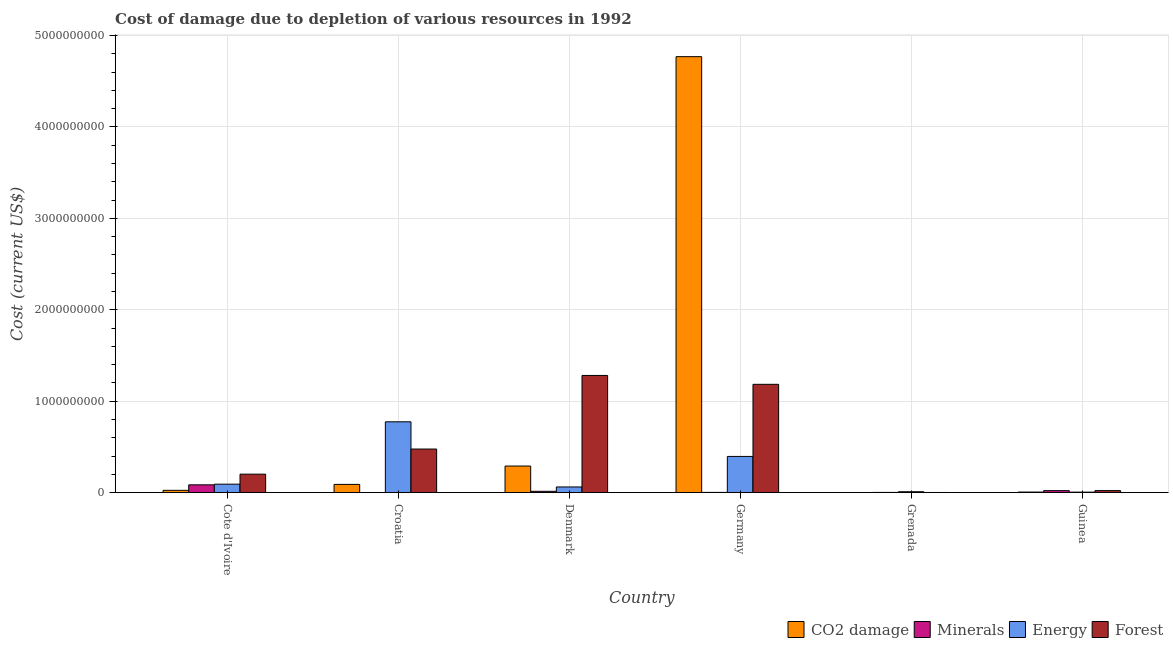How many different coloured bars are there?
Provide a short and direct response. 4. Are the number of bars per tick equal to the number of legend labels?
Give a very brief answer. Yes. How many bars are there on the 4th tick from the left?
Offer a terse response. 4. What is the label of the 2nd group of bars from the left?
Your answer should be compact. Croatia. In how many cases, is the number of bars for a given country not equal to the number of legend labels?
Ensure brevity in your answer.  0. What is the cost of damage due to depletion of minerals in Grenada?
Ensure brevity in your answer.  2.00e+06. Across all countries, what is the maximum cost of damage due to depletion of coal?
Ensure brevity in your answer.  4.77e+09. Across all countries, what is the minimum cost of damage due to depletion of minerals?
Keep it short and to the point. 9.29e+05. In which country was the cost of damage due to depletion of energy maximum?
Your response must be concise. Croatia. In which country was the cost of damage due to depletion of forests minimum?
Give a very brief answer. Grenada. What is the total cost of damage due to depletion of forests in the graph?
Provide a succinct answer. 3.17e+09. What is the difference between the cost of damage due to depletion of forests in Germany and that in Guinea?
Make the answer very short. 1.16e+09. What is the difference between the cost of damage due to depletion of forests in Grenada and the cost of damage due to depletion of energy in Cote d'Ivoire?
Provide a succinct answer. -9.10e+07. What is the average cost of damage due to depletion of coal per country?
Provide a succinct answer. 8.63e+08. What is the difference between the cost of damage due to depletion of minerals and cost of damage due to depletion of coal in Denmark?
Your response must be concise. -2.76e+08. In how many countries, is the cost of damage due to depletion of minerals greater than 200000000 US$?
Provide a succinct answer. 0. What is the ratio of the cost of damage due to depletion of minerals in Cote d'Ivoire to that in Grenada?
Your response must be concise. 42.4. Is the cost of damage due to depletion of energy in Croatia less than that in Grenada?
Offer a very short reply. No. What is the difference between the highest and the second highest cost of damage due to depletion of forests?
Offer a very short reply. 9.71e+07. What is the difference between the highest and the lowest cost of damage due to depletion of coal?
Your answer should be very brief. 4.77e+09. Is it the case that in every country, the sum of the cost of damage due to depletion of coal and cost of damage due to depletion of energy is greater than the sum of cost of damage due to depletion of forests and cost of damage due to depletion of minerals?
Make the answer very short. No. What does the 2nd bar from the left in Denmark represents?
Offer a terse response. Minerals. What does the 4th bar from the right in Croatia represents?
Make the answer very short. CO2 damage. How many bars are there?
Ensure brevity in your answer.  24. How many countries are there in the graph?
Offer a terse response. 6. What is the difference between two consecutive major ticks on the Y-axis?
Make the answer very short. 1.00e+09. Are the values on the major ticks of Y-axis written in scientific E-notation?
Your answer should be compact. No. Where does the legend appear in the graph?
Your response must be concise. Bottom right. How many legend labels are there?
Your response must be concise. 4. How are the legend labels stacked?
Your answer should be very brief. Horizontal. What is the title of the graph?
Keep it short and to the point. Cost of damage due to depletion of various resources in 1992 . What is the label or title of the X-axis?
Your response must be concise. Country. What is the label or title of the Y-axis?
Offer a very short reply. Cost (current US$). What is the Cost (current US$) of CO2 damage in Cote d'Ivoire?
Provide a short and direct response. 2.47e+07. What is the Cost (current US$) of Minerals in Cote d'Ivoire?
Your response must be concise. 8.49e+07. What is the Cost (current US$) in Energy in Cote d'Ivoire?
Make the answer very short. 9.22e+07. What is the Cost (current US$) of Forest in Cote d'Ivoire?
Provide a succinct answer. 2.01e+08. What is the Cost (current US$) of CO2 damage in Croatia?
Keep it short and to the point. 8.97e+07. What is the Cost (current US$) in Minerals in Croatia?
Give a very brief answer. 9.29e+05. What is the Cost (current US$) of Energy in Croatia?
Your answer should be very brief. 7.74e+08. What is the Cost (current US$) in Forest in Croatia?
Your answer should be very brief. 4.76e+08. What is the Cost (current US$) of CO2 damage in Denmark?
Your answer should be very brief. 2.90e+08. What is the Cost (current US$) in Minerals in Denmark?
Your answer should be compact. 1.40e+07. What is the Cost (current US$) in Energy in Denmark?
Your answer should be very brief. 6.16e+07. What is the Cost (current US$) in Forest in Denmark?
Provide a short and direct response. 1.28e+09. What is the Cost (current US$) of CO2 damage in Germany?
Your answer should be compact. 4.77e+09. What is the Cost (current US$) in Minerals in Germany?
Keep it short and to the point. 2.06e+06. What is the Cost (current US$) of Energy in Germany?
Provide a succinct answer. 3.95e+08. What is the Cost (current US$) of Forest in Germany?
Your answer should be very brief. 1.18e+09. What is the Cost (current US$) of CO2 damage in Grenada?
Offer a terse response. 6.47e+05. What is the Cost (current US$) of Minerals in Grenada?
Provide a short and direct response. 2.00e+06. What is the Cost (current US$) in Energy in Grenada?
Give a very brief answer. 9.46e+06. What is the Cost (current US$) in Forest in Grenada?
Make the answer very short. 1.17e+06. What is the Cost (current US$) in CO2 damage in Guinea?
Provide a short and direct response. 5.74e+06. What is the Cost (current US$) in Minerals in Guinea?
Make the answer very short. 2.13e+07. What is the Cost (current US$) of Energy in Guinea?
Give a very brief answer. 4.93e+06. What is the Cost (current US$) in Forest in Guinea?
Keep it short and to the point. 2.18e+07. Across all countries, what is the maximum Cost (current US$) in CO2 damage?
Ensure brevity in your answer.  4.77e+09. Across all countries, what is the maximum Cost (current US$) of Minerals?
Your answer should be compact. 8.49e+07. Across all countries, what is the maximum Cost (current US$) in Energy?
Ensure brevity in your answer.  7.74e+08. Across all countries, what is the maximum Cost (current US$) of Forest?
Keep it short and to the point. 1.28e+09. Across all countries, what is the minimum Cost (current US$) of CO2 damage?
Give a very brief answer. 6.47e+05. Across all countries, what is the minimum Cost (current US$) of Minerals?
Your response must be concise. 9.29e+05. Across all countries, what is the minimum Cost (current US$) in Energy?
Offer a terse response. 4.93e+06. Across all countries, what is the minimum Cost (current US$) of Forest?
Offer a very short reply. 1.17e+06. What is the total Cost (current US$) in CO2 damage in the graph?
Your answer should be very brief. 5.18e+09. What is the total Cost (current US$) of Minerals in the graph?
Your response must be concise. 1.25e+08. What is the total Cost (current US$) of Energy in the graph?
Your answer should be very brief. 1.34e+09. What is the total Cost (current US$) of Forest in the graph?
Provide a short and direct response. 3.17e+09. What is the difference between the Cost (current US$) in CO2 damage in Cote d'Ivoire and that in Croatia?
Offer a terse response. -6.49e+07. What is the difference between the Cost (current US$) of Minerals in Cote d'Ivoire and that in Croatia?
Ensure brevity in your answer.  8.40e+07. What is the difference between the Cost (current US$) in Energy in Cote d'Ivoire and that in Croatia?
Provide a succinct answer. -6.82e+08. What is the difference between the Cost (current US$) of Forest in Cote d'Ivoire and that in Croatia?
Your answer should be very brief. -2.75e+08. What is the difference between the Cost (current US$) of CO2 damage in Cote d'Ivoire and that in Denmark?
Your response must be concise. -2.66e+08. What is the difference between the Cost (current US$) of Minerals in Cote d'Ivoire and that in Denmark?
Provide a succinct answer. 7.09e+07. What is the difference between the Cost (current US$) of Energy in Cote d'Ivoire and that in Denmark?
Provide a succinct answer. 3.06e+07. What is the difference between the Cost (current US$) in Forest in Cote d'Ivoire and that in Denmark?
Your answer should be compact. -1.08e+09. What is the difference between the Cost (current US$) in CO2 damage in Cote d'Ivoire and that in Germany?
Your answer should be very brief. -4.74e+09. What is the difference between the Cost (current US$) of Minerals in Cote d'Ivoire and that in Germany?
Your answer should be very brief. 8.28e+07. What is the difference between the Cost (current US$) in Energy in Cote d'Ivoire and that in Germany?
Make the answer very short. -3.03e+08. What is the difference between the Cost (current US$) of Forest in Cote d'Ivoire and that in Germany?
Make the answer very short. -9.83e+08. What is the difference between the Cost (current US$) of CO2 damage in Cote d'Ivoire and that in Grenada?
Provide a short and direct response. 2.41e+07. What is the difference between the Cost (current US$) of Minerals in Cote d'Ivoire and that in Grenada?
Keep it short and to the point. 8.29e+07. What is the difference between the Cost (current US$) of Energy in Cote d'Ivoire and that in Grenada?
Your answer should be very brief. 8.27e+07. What is the difference between the Cost (current US$) of Forest in Cote d'Ivoire and that in Grenada?
Provide a succinct answer. 2.00e+08. What is the difference between the Cost (current US$) of CO2 damage in Cote d'Ivoire and that in Guinea?
Offer a very short reply. 1.90e+07. What is the difference between the Cost (current US$) of Minerals in Cote d'Ivoire and that in Guinea?
Give a very brief answer. 6.36e+07. What is the difference between the Cost (current US$) in Energy in Cote d'Ivoire and that in Guinea?
Your answer should be compact. 8.73e+07. What is the difference between the Cost (current US$) in Forest in Cote d'Ivoire and that in Guinea?
Your response must be concise. 1.80e+08. What is the difference between the Cost (current US$) of CO2 damage in Croatia and that in Denmark?
Your response must be concise. -2.01e+08. What is the difference between the Cost (current US$) of Minerals in Croatia and that in Denmark?
Ensure brevity in your answer.  -1.31e+07. What is the difference between the Cost (current US$) in Energy in Croatia and that in Denmark?
Your answer should be very brief. 7.13e+08. What is the difference between the Cost (current US$) in Forest in Croatia and that in Denmark?
Make the answer very short. -8.05e+08. What is the difference between the Cost (current US$) in CO2 damage in Croatia and that in Germany?
Provide a short and direct response. -4.68e+09. What is the difference between the Cost (current US$) of Minerals in Croatia and that in Germany?
Your answer should be compact. -1.14e+06. What is the difference between the Cost (current US$) in Energy in Croatia and that in Germany?
Your response must be concise. 3.79e+08. What is the difference between the Cost (current US$) of Forest in Croatia and that in Germany?
Offer a very short reply. -7.08e+08. What is the difference between the Cost (current US$) in CO2 damage in Croatia and that in Grenada?
Make the answer very short. 8.90e+07. What is the difference between the Cost (current US$) of Minerals in Croatia and that in Grenada?
Make the answer very short. -1.07e+06. What is the difference between the Cost (current US$) in Energy in Croatia and that in Grenada?
Keep it short and to the point. 7.65e+08. What is the difference between the Cost (current US$) in Forest in Croatia and that in Grenada?
Your answer should be very brief. 4.75e+08. What is the difference between the Cost (current US$) of CO2 damage in Croatia and that in Guinea?
Provide a short and direct response. 8.39e+07. What is the difference between the Cost (current US$) of Minerals in Croatia and that in Guinea?
Give a very brief answer. -2.03e+07. What is the difference between the Cost (current US$) of Energy in Croatia and that in Guinea?
Make the answer very short. 7.69e+08. What is the difference between the Cost (current US$) of Forest in Croatia and that in Guinea?
Make the answer very short. 4.55e+08. What is the difference between the Cost (current US$) in CO2 damage in Denmark and that in Germany?
Provide a short and direct response. -4.48e+09. What is the difference between the Cost (current US$) of Minerals in Denmark and that in Germany?
Keep it short and to the point. 1.20e+07. What is the difference between the Cost (current US$) of Energy in Denmark and that in Germany?
Make the answer very short. -3.34e+08. What is the difference between the Cost (current US$) in Forest in Denmark and that in Germany?
Ensure brevity in your answer.  9.71e+07. What is the difference between the Cost (current US$) in CO2 damage in Denmark and that in Grenada?
Make the answer very short. 2.90e+08. What is the difference between the Cost (current US$) in Minerals in Denmark and that in Grenada?
Offer a terse response. 1.20e+07. What is the difference between the Cost (current US$) of Energy in Denmark and that in Grenada?
Keep it short and to the point. 5.21e+07. What is the difference between the Cost (current US$) in Forest in Denmark and that in Grenada?
Keep it short and to the point. 1.28e+09. What is the difference between the Cost (current US$) of CO2 damage in Denmark and that in Guinea?
Provide a short and direct response. 2.85e+08. What is the difference between the Cost (current US$) of Minerals in Denmark and that in Guinea?
Offer a terse response. -7.24e+06. What is the difference between the Cost (current US$) of Energy in Denmark and that in Guinea?
Keep it short and to the point. 5.67e+07. What is the difference between the Cost (current US$) in Forest in Denmark and that in Guinea?
Provide a short and direct response. 1.26e+09. What is the difference between the Cost (current US$) in CO2 damage in Germany and that in Grenada?
Your answer should be very brief. 4.77e+09. What is the difference between the Cost (current US$) in Minerals in Germany and that in Grenada?
Give a very brief answer. 6.26e+04. What is the difference between the Cost (current US$) in Energy in Germany and that in Grenada?
Your answer should be very brief. 3.86e+08. What is the difference between the Cost (current US$) in Forest in Germany and that in Grenada?
Your response must be concise. 1.18e+09. What is the difference between the Cost (current US$) in CO2 damage in Germany and that in Guinea?
Your answer should be very brief. 4.76e+09. What is the difference between the Cost (current US$) in Minerals in Germany and that in Guinea?
Offer a very short reply. -1.92e+07. What is the difference between the Cost (current US$) in Energy in Germany and that in Guinea?
Give a very brief answer. 3.91e+08. What is the difference between the Cost (current US$) of Forest in Germany and that in Guinea?
Your response must be concise. 1.16e+09. What is the difference between the Cost (current US$) of CO2 damage in Grenada and that in Guinea?
Offer a very short reply. -5.10e+06. What is the difference between the Cost (current US$) of Minerals in Grenada and that in Guinea?
Ensure brevity in your answer.  -1.93e+07. What is the difference between the Cost (current US$) in Energy in Grenada and that in Guinea?
Your answer should be compact. 4.53e+06. What is the difference between the Cost (current US$) of Forest in Grenada and that in Guinea?
Your answer should be compact. -2.06e+07. What is the difference between the Cost (current US$) of CO2 damage in Cote d'Ivoire and the Cost (current US$) of Minerals in Croatia?
Offer a very short reply. 2.38e+07. What is the difference between the Cost (current US$) of CO2 damage in Cote d'Ivoire and the Cost (current US$) of Energy in Croatia?
Give a very brief answer. -7.50e+08. What is the difference between the Cost (current US$) in CO2 damage in Cote d'Ivoire and the Cost (current US$) in Forest in Croatia?
Offer a terse response. -4.52e+08. What is the difference between the Cost (current US$) of Minerals in Cote d'Ivoire and the Cost (current US$) of Energy in Croatia?
Your answer should be compact. -6.89e+08. What is the difference between the Cost (current US$) of Minerals in Cote d'Ivoire and the Cost (current US$) of Forest in Croatia?
Give a very brief answer. -3.91e+08. What is the difference between the Cost (current US$) in Energy in Cote d'Ivoire and the Cost (current US$) in Forest in Croatia?
Keep it short and to the point. -3.84e+08. What is the difference between the Cost (current US$) of CO2 damage in Cote d'Ivoire and the Cost (current US$) of Minerals in Denmark?
Your answer should be compact. 1.07e+07. What is the difference between the Cost (current US$) in CO2 damage in Cote d'Ivoire and the Cost (current US$) in Energy in Denmark?
Your answer should be compact. -3.69e+07. What is the difference between the Cost (current US$) in CO2 damage in Cote d'Ivoire and the Cost (current US$) in Forest in Denmark?
Make the answer very short. -1.26e+09. What is the difference between the Cost (current US$) in Minerals in Cote d'Ivoire and the Cost (current US$) in Energy in Denmark?
Make the answer very short. 2.33e+07. What is the difference between the Cost (current US$) of Minerals in Cote d'Ivoire and the Cost (current US$) of Forest in Denmark?
Keep it short and to the point. -1.20e+09. What is the difference between the Cost (current US$) of Energy in Cote d'Ivoire and the Cost (current US$) of Forest in Denmark?
Your answer should be compact. -1.19e+09. What is the difference between the Cost (current US$) of CO2 damage in Cote d'Ivoire and the Cost (current US$) of Minerals in Germany?
Make the answer very short. 2.27e+07. What is the difference between the Cost (current US$) of CO2 damage in Cote d'Ivoire and the Cost (current US$) of Energy in Germany?
Keep it short and to the point. -3.71e+08. What is the difference between the Cost (current US$) of CO2 damage in Cote d'Ivoire and the Cost (current US$) of Forest in Germany?
Ensure brevity in your answer.  -1.16e+09. What is the difference between the Cost (current US$) in Minerals in Cote d'Ivoire and the Cost (current US$) in Energy in Germany?
Your answer should be compact. -3.11e+08. What is the difference between the Cost (current US$) of Minerals in Cote d'Ivoire and the Cost (current US$) of Forest in Germany?
Ensure brevity in your answer.  -1.10e+09. What is the difference between the Cost (current US$) of Energy in Cote d'Ivoire and the Cost (current US$) of Forest in Germany?
Your answer should be very brief. -1.09e+09. What is the difference between the Cost (current US$) of CO2 damage in Cote d'Ivoire and the Cost (current US$) of Minerals in Grenada?
Your answer should be compact. 2.27e+07. What is the difference between the Cost (current US$) in CO2 damage in Cote d'Ivoire and the Cost (current US$) in Energy in Grenada?
Your answer should be compact. 1.53e+07. What is the difference between the Cost (current US$) in CO2 damage in Cote d'Ivoire and the Cost (current US$) in Forest in Grenada?
Ensure brevity in your answer.  2.35e+07. What is the difference between the Cost (current US$) of Minerals in Cote d'Ivoire and the Cost (current US$) of Energy in Grenada?
Provide a succinct answer. 7.55e+07. What is the difference between the Cost (current US$) in Minerals in Cote d'Ivoire and the Cost (current US$) in Forest in Grenada?
Offer a terse response. 8.37e+07. What is the difference between the Cost (current US$) of Energy in Cote d'Ivoire and the Cost (current US$) of Forest in Grenada?
Make the answer very short. 9.10e+07. What is the difference between the Cost (current US$) in CO2 damage in Cote d'Ivoire and the Cost (current US$) in Minerals in Guinea?
Your answer should be compact. 3.45e+06. What is the difference between the Cost (current US$) in CO2 damage in Cote d'Ivoire and the Cost (current US$) in Energy in Guinea?
Keep it short and to the point. 1.98e+07. What is the difference between the Cost (current US$) of CO2 damage in Cote d'Ivoire and the Cost (current US$) of Forest in Guinea?
Keep it short and to the point. 2.97e+06. What is the difference between the Cost (current US$) of Minerals in Cote d'Ivoire and the Cost (current US$) of Energy in Guinea?
Offer a very short reply. 8.00e+07. What is the difference between the Cost (current US$) of Minerals in Cote d'Ivoire and the Cost (current US$) of Forest in Guinea?
Your answer should be compact. 6.32e+07. What is the difference between the Cost (current US$) in Energy in Cote d'Ivoire and the Cost (current US$) in Forest in Guinea?
Provide a succinct answer. 7.05e+07. What is the difference between the Cost (current US$) in CO2 damage in Croatia and the Cost (current US$) in Minerals in Denmark?
Ensure brevity in your answer.  7.56e+07. What is the difference between the Cost (current US$) of CO2 damage in Croatia and the Cost (current US$) of Energy in Denmark?
Your answer should be very brief. 2.81e+07. What is the difference between the Cost (current US$) of CO2 damage in Croatia and the Cost (current US$) of Forest in Denmark?
Give a very brief answer. -1.19e+09. What is the difference between the Cost (current US$) of Minerals in Croatia and the Cost (current US$) of Energy in Denmark?
Your answer should be compact. -6.07e+07. What is the difference between the Cost (current US$) in Minerals in Croatia and the Cost (current US$) in Forest in Denmark?
Provide a short and direct response. -1.28e+09. What is the difference between the Cost (current US$) of Energy in Croatia and the Cost (current US$) of Forest in Denmark?
Offer a terse response. -5.07e+08. What is the difference between the Cost (current US$) of CO2 damage in Croatia and the Cost (current US$) of Minerals in Germany?
Provide a short and direct response. 8.76e+07. What is the difference between the Cost (current US$) in CO2 damage in Croatia and the Cost (current US$) in Energy in Germany?
Offer a very short reply. -3.06e+08. What is the difference between the Cost (current US$) of CO2 damage in Croatia and the Cost (current US$) of Forest in Germany?
Your answer should be compact. -1.09e+09. What is the difference between the Cost (current US$) in Minerals in Croatia and the Cost (current US$) in Energy in Germany?
Keep it short and to the point. -3.95e+08. What is the difference between the Cost (current US$) in Minerals in Croatia and the Cost (current US$) in Forest in Germany?
Keep it short and to the point. -1.18e+09. What is the difference between the Cost (current US$) of Energy in Croatia and the Cost (current US$) of Forest in Germany?
Provide a succinct answer. -4.10e+08. What is the difference between the Cost (current US$) of CO2 damage in Croatia and the Cost (current US$) of Minerals in Grenada?
Give a very brief answer. 8.77e+07. What is the difference between the Cost (current US$) in CO2 damage in Croatia and the Cost (current US$) in Energy in Grenada?
Offer a terse response. 8.02e+07. What is the difference between the Cost (current US$) of CO2 damage in Croatia and the Cost (current US$) of Forest in Grenada?
Offer a very short reply. 8.85e+07. What is the difference between the Cost (current US$) in Minerals in Croatia and the Cost (current US$) in Energy in Grenada?
Keep it short and to the point. -8.53e+06. What is the difference between the Cost (current US$) in Minerals in Croatia and the Cost (current US$) in Forest in Grenada?
Ensure brevity in your answer.  -2.42e+05. What is the difference between the Cost (current US$) in Energy in Croatia and the Cost (current US$) in Forest in Grenada?
Offer a terse response. 7.73e+08. What is the difference between the Cost (current US$) of CO2 damage in Croatia and the Cost (current US$) of Minerals in Guinea?
Your answer should be compact. 6.84e+07. What is the difference between the Cost (current US$) in CO2 damage in Croatia and the Cost (current US$) in Energy in Guinea?
Provide a short and direct response. 8.47e+07. What is the difference between the Cost (current US$) of CO2 damage in Croatia and the Cost (current US$) of Forest in Guinea?
Give a very brief answer. 6.79e+07. What is the difference between the Cost (current US$) in Minerals in Croatia and the Cost (current US$) in Energy in Guinea?
Make the answer very short. -4.00e+06. What is the difference between the Cost (current US$) of Minerals in Croatia and the Cost (current US$) of Forest in Guinea?
Ensure brevity in your answer.  -2.08e+07. What is the difference between the Cost (current US$) of Energy in Croatia and the Cost (current US$) of Forest in Guinea?
Provide a succinct answer. 7.52e+08. What is the difference between the Cost (current US$) of CO2 damage in Denmark and the Cost (current US$) of Minerals in Germany?
Offer a terse response. 2.88e+08. What is the difference between the Cost (current US$) of CO2 damage in Denmark and the Cost (current US$) of Energy in Germany?
Provide a short and direct response. -1.05e+08. What is the difference between the Cost (current US$) in CO2 damage in Denmark and the Cost (current US$) in Forest in Germany?
Make the answer very short. -8.94e+08. What is the difference between the Cost (current US$) of Minerals in Denmark and the Cost (current US$) of Energy in Germany?
Make the answer very short. -3.81e+08. What is the difference between the Cost (current US$) of Minerals in Denmark and the Cost (current US$) of Forest in Germany?
Offer a terse response. -1.17e+09. What is the difference between the Cost (current US$) of Energy in Denmark and the Cost (current US$) of Forest in Germany?
Provide a succinct answer. -1.12e+09. What is the difference between the Cost (current US$) of CO2 damage in Denmark and the Cost (current US$) of Minerals in Grenada?
Offer a terse response. 2.88e+08. What is the difference between the Cost (current US$) in CO2 damage in Denmark and the Cost (current US$) in Energy in Grenada?
Your answer should be very brief. 2.81e+08. What is the difference between the Cost (current US$) of CO2 damage in Denmark and the Cost (current US$) of Forest in Grenada?
Your response must be concise. 2.89e+08. What is the difference between the Cost (current US$) of Minerals in Denmark and the Cost (current US$) of Energy in Grenada?
Your answer should be compact. 4.57e+06. What is the difference between the Cost (current US$) in Minerals in Denmark and the Cost (current US$) in Forest in Grenada?
Provide a short and direct response. 1.29e+07. What is the difference between the Cost (current US$) of Energy in Denmark and the Cost (current US$) of Forest in Grenada?
Make the answer very short. 6.04e+07. What is the difference between the Cost (current US$) in CO2 damage in Denmark and the Cost (current US$) in Minerals in Guinea?
Provide a short and direct response. 2.69e+08. What is the difference between the Cost (current US$) of CO2 damage in Denmark and the Cost (current US$) of Energy in Guinea?
Ensure brevity in your answer.  2.85e+08. What is the difference between the Cost (current US$) in CO2 damage in Denmark and the Cost (current US$) in Forest in Guinea?
Provide a succinct answer. 2.69e+08. What is the difference between the Cost (current US$) in Minerals in Denmark and the Cost (current US$) in Energy in Guinea?
Your answer should be compact. 9.09e+06. What is the difference between the Cost (current US$) of Minerals in Denmark and the Cost (current US$) of Forest in Guinea?
Keep it short and to the point. -7.73e+06. What is the difference between the Cost (current US$) of Energy in Denmark and the Cost (current US$) of Forest in Guinea?
Keep it short and to the point. 3.98e+07. What is the difference between the Cost (current US$) of CO2 damage in Germany and the Cost (current US$) of Minerals in Grenada?
Your response must be concise. 4.77e+09. What is the difference between the Cost (current US$) in CO2 damage in Germany and the Cost (current US$) in Energy in Grenada?
Give a very brief answer. 4.76e+09. What is the difference between the Cost (current US$) of CO2 damage in Germany and the Cost (current US$) of Forest in Grenada?
Keep it short and to the point. 4.77e+09. What is the difference between the Cost (current US$) of Minerals in Germany and the Cost (current US$) of Energy in Grenada?
Make the answer very short. -7.39e+06. What is the difference between the Cost (current US$) in Minerals in Germany and the Cost (current US$) in Forest in Grenada?
Offer a very short reply. 8.94e+05. What is the difference between the Cost (current US$) in Energy in Germany and the Cost (current US$) in Forest in Grenada?
Provide a short and direct response. 3.94e+08. What is the difference between the Cost (current US$) of CO2 damage in Germany and the Cost (current US$) of Minerals in Guinea?
Keep it short and to the point. 4.75e+09. What is the difference between the Cost (current US$) in CO2 damage in Germany and the Cost (current US$) in Energy in Guinea?
Offer a terse response. 4.76e+09. What is the difference between the Cost (current US$) of CO2 damage in Germany and the Cost (current US$) of Forest in Guinea?
Ensure brevity in your answer.  4.75e+09. What is the difference between the Cost (current US$) of Minerals in Germany and the Cost (current US$) of Energy in Guinea?
Your response must be concise. -2.87e+06. What is the difference between the Cost (current US$) in Minerals in Germany and the Cost (current US$) in Forest in Guinea?
Your response must be concise. -1.97e+07. What is the difference between the Cost (current US$) in Energy in Germany and the Cost (current US$) in Forest in Guinea?
Your answer should be very brief. 3.74e+08. What is the difference between the Cost (current US$) of CO2 damage in Grenada and the Cost (current US$) of Minerals in Guinea?
Provide a short and direct response. -2.06e+07. What is the difference between the Cost (current US$) of CO2 damage in Grenada and the Cost (current US$) of Energy in Guinea?
Ensure brevity in your answer.  -4.29e+06. What is the difference between the Cost (current US$) in CO2 damage in Grenada and the Cost (current US$) in Forest in Guinea?
Give a very brief answer. -2.11e+07. What is the difference between the Cost (current US$) of Minerals in Grenada and the Cost (current US$) of Energy in Guinea?
Keep it short and to the point. -2.93e+06. What is the difference between the Cost (current US$) of Minerals in Grenada and the Cost (current US$) of Forest in Guinea?
Provide a short and direct response. -1.97e+07. What is the difference between the Cost (current US$) of Energy in Grenada and the Cost (current US$) of Forest in Guinea?
Offer a very short reply. -1.23e+07. What is the average Cost (current US$) of CO2 damage per country?
Keep it short and to the point. 8.63e+08. What is the average Cost (current US$) in Minerals per country?
Give a very brief answer. 2.09e+07. What is the average Cost (current US$) in Energy per country?
Ensure brevity in your answer.  2.23e+08. What is the average Cost (current US$) in Forest per country?
Make the answer very short. 5.28e+08. What is the difference between the Cost (current US$) of CO2 damage and Cost (current US$) of Minerals in Cote d'Ivoire?
Your answer should be very brief. -6.02e+07. What is the difference between the Cost (current US$) in CO2 damage and Cost (current US$) in Energy in Cote d'Ivoire?
Offer a terse response. -6.75e+07. What is the difference between the Cost (current US$) in CO2 damage and Cost (current US$) in Forest in Cote d'Ivoire?
Provide a short and direct response. -1.77e+08. What is the difference between the Cost (current US$) of Minerals and Cost (current US$) of Energy in Cote d'Ivoire?
Keep it short and to the point. -7.29e+06. What is the difference between the Cost (current US$) in Minerals and Cost (current US$) in Forest in Cote d'Ivoire?
Provide a short and direct response. -1.17e+08. What is the difference between the Cost (current US$) in Energy and Cost (current US$) in Forest in Cote d'Ivoire?
Give a very brief answer. -1.09e+08. What is the difference between the Cost (current US$) in CO2 damage and Cost (current US$) in Minerals in Croatia?
Your answer should be compact. 8.87e+07. What is the difference between the Cost (current US$) in CO2 damage and Cost (current US$) in Energy in Croatia?
Keep it short and to the point. -6.85e+08. What is the difference between the Cost (current US$) of CO2 damage and Cost (current US$) of Forest in Croatia?
Make the answer very short. -3.87e+08. What is the difference between the Cost (current US$) of Minerals and Cost (current US$) of Energy in Croatia?
Your answer should be very brief. -7.73e+08. What is the difference between the Cost (current US$) in Minerals and Cost (current US$) in Forest in Croatia?
Your response must be concise. -4.75e+08. What is the difference between the Cost (current US$) of Energy and Cost (current US$) of Forest in Croatia?
Your response must be concise. 2.98e+08. What is the difference between the Cost (current US$) of CO2 damage and Cost (current US$) of Minerals in Denmark?
Offer a terse response. 2.76e+08. What is the difference between the Cost (current US$) in CO2 damage and Cost (current US$) in Energy in Denmark?
Offer a terse response. 2.29e+08. What is the difference between the Cost (current US$) in CO2 damage and Cost (current US$) in Forest in Denmark?
Your answer should be very brief. -9.91e+08. What is the difference between the Cost (current US$) of Minerals and Cost (current US$) of Energy in Denmark?
Offer a terse response. -4.76e+07. What is the difference between the Cost (current US$) of Minerals and Cost (current US$) of Forest in Denmark?
Ensure brevity in your answer.  -1.27e+09. What is the difference between the Cost (current US$) in Energy and Cost (current US$) in Forest in Denmark?
Provide a succinct answer. -1.22e+09. What is the difference between the Cost (current US$) in CO2 damage and Cost (current US$) in Minerals in Germany?
Provide a succinct answer. 4.77e+09. What is the difference between the Cost (current US$) in CO2 damage and Cost (current US$) in Energy in Germany?
Ensure brevity in your answer.  4.37e+09. What is the difference between the Cost (current US$) of CO2 damage and Cost (current US$) of Forest in Germany?
Give a very brief answer. 3.58e+09. What is the difference between the Cost (current US$) of Minerals and Cost (current US$) of Energy in Germany?
Give a very brief answer. -3.93e+08. What is the difference between the Cost (current US$) in Minerals and Cost (current US$) in Forest in Germany?
Provide a succinct answer. -1.18e+09. What is the difference between the Cost (current US$) in Energy and Cost (current US$) in Forest in Germany?
Your answer should be very brief. -7.89e+08. What is the difference between the Cost (current US$) in CO2 damage and Cost (current US$) in Minerals in Grenada?
Provide a succinct answer. -1.36e+06. What is the difference between the Cost (current US$) in CO2 damage and Cost (current US$) in Energy in Grenada?
Give a very brief answer. -8.81e+06. What is the difference between the Cost (current US$) of CO2 damage and Cost (current US$) of Forest in Grenada?
Provide a succinct answer. -5.24e+05. What is the difference between the Cost (current US$) in Minerals and Cost (current US$) in Energy in Grenada?
Provide a short and direct response. -7.46e+06. What is the difference between the Cost (current US$) in Minerals and Cost (current US$) in Forest in Grenada?
Your response must be concise. 8.32e+05. What is the difference between the Cost (current US$) of Energy and Cost (current US$) of Forest in Grenada?
Make the answer very short. 8.29e+06. What is the difference between the Cost (current US$) of CO2 damage and Cost (current US$) of Minerals in Guinea?
Provide a short and direct response. -1.55e+07. What is the difference between the Cost (current US$) in CO2 damage and Cost (current US$) in Energy in Guinea?
Make the answer very short. 8.11e+05. What is the difference between the Cost (current US$) of CO2 damage and Cost (current US$) of Forest in Guinea?
Provide a short and direct response. -1.60e+07. What is the difference between the Cost (current US$) in Minerals and Cost (current US$) in Energy in Guinea?
Your answer should be compact. 1.63e+07. What is the difference between the Cost (current US$) of Minerals and Cost (current US$) of Forest in Guinea?
Give a very brief answer. -4.84e+05. What is the difference between the Cost (current US$) in Energy and Cost (current US$) in Forest in Guinea?
Make the answer very short. -1.68e+07. What is the ratio of the Cost (current US$) of CO2 damage in Cote d'Ivoire to that in Croatia?
Make the answer very short. 0.28. What is the ratio of the Cost (current US$) in Minerals in Cote d'Ivoire to that in Croatia?
Ensure brevity in your answer.  91.43. What is the ratio of the Cost (current US$) in Energy in Cote d'Ivoire to that in Croatia?
Give a very brief answer. 0.12. What is the ratio of the Cost (current US$) of Forest in Cote d'Ivoire to that in Croatia?
Give a very brief answer. 0.42. What is the ratio of the Cost (current US$) of CO2 damage in Cote d'Ivoire to that in Denmark?
Offer a very short reply. 0.09. What is the ratio of the Cost (current US$) of Minerals in Cote d'Ivoire to that in Denmark?
Your response must be concise. 6.05. What is the ratio of the Cost (current US$) of Energy in Cote d'Ivoire to that in Denmark?
Keep it short and to the point. 1.5. What is the ratio of the Cost (current US$) of Forest in Cote d'Ivoire to that in Denmark?
Offer a terse response. 0.16. What is the ratio of the Cost (current US$) of CO2 damage in Cote d'Ivoire to that in Germany?
Offer a very short reply. 0.01. What is the ratio of the Cost (current US$) in Minerals in Cote d'Ivoire to that in Germany?
Provide a succinct answer. 41.12. What is the ratio of the Cost (current US$) of Energy in Cote d'Ivoire to that in Germany?
Keep it short and to the point. 0.23. What is the ratio of the Cost (current US$) in Forest in Cote d'Ivoire to that in Germany?
Your response must be concise. 0.17. What is the ratio of the Cost (current US$) in CO2 damage in Cote d'Ivoire to that in Grenada?
Offer a terse response. 38.21. What is the ratio of the Cost (current US$) of Minerals in Cote d'Ivoire to that in Grenada?
Your answer should be compact. 42.4. What is the ratio of the Cost (current US$) in Energy in Cote d'Ivoire to that in Grenada?
Your answer should be very brief. 9.75. What is the ratio of the Cost (current US$) of Forest in Cote d'Ivoire to that in Grenada?
Provide a short and direct response. 172.1. What is the ratio of the Cost (current US$) of CO2 damage in Cote d'Ivoire to that in Guinea?
Offer a terse response. 4.3. What is the ratio of the Cost (current US$) in Minerals in Cote d'Ivoire to that in Guinea?
Your answer should be very brief. 3.99. What is the ratio of the Cost (current US$) of Energy in Cote d'Ivoire to that in Guinea?
Make the answer very short. 18.69. What is the ratio of the Cost (current US$) in Forest in Cote d'Ivoire to that in Guinea?
Give a very brief answer. 9.26. What is the ratio of the Cost (current US$) in CO2 damage in Croatia to that in Denmark?
Give a very brief answer. 0.31. What is the ratio of the Cost (current US$) in Minerals in Croatia to that in Denmark?
Your response must be concise. 0.07. What is the ratio of the Cost (current US$) of Energy in Croatia to that in Denmark?
Give a very brief answer. 12.57. What is the ratio of the Cost (current US$) of Forest in Croatia to that in Denmark?
Provide a short and direct response. 0.37. What is the ratio of the Cost (current US$) in CO2 damage in Croatia to that in Germany?
Make the answer very short. 0.02. What is the ratio of the Cost (current US$) in Minerals in Croatia to that in Germany?
Provide a succinct answer. 0.45. What is the ratio of the Cost (current US$) of Energy in Croatia to that in Germany?
Your answer should be very brief. 1.96. What is the ratio of the Cost (current US$) of Forest in Croatia to that in Germany?
Keep it short and to the point. 0.4. What is the ratio of the Cost (current US$) of CO2 damage in Croatia to that in Grenada?
Ensure brevity in your answer.  138.61. What is the ratio of the Cost (current US$) in Minerals in Croatia to that in Grenada?
Make the answer very short. 0.46. What is the ratio of the Cost (current US$) in Energy in Croatia to that in Grenada?
Give a very brief answer. 81.84. What is the ratio of the Cost (current US$) in Forest in Croatia to that in Grenada?
Make the answer very short. 406.86. What is the ratio of the Cost (current US$) of CO2 damage in Croatia to that in Guinea?
Offer a terse response. 15.61. What is the ratio of the Cost (current US$) of Minerals in Croatia to that in Guinea?
Your answer should be compact. 0.04. What is the ratio of the Cost (current US$) in Energy in Croatia to that in Guinea?
Your answer should be very brief. 156.96. What is the ratio of the Cost (current US$) in Forest in Croatia to that in Guinea?
Make the answer very short. 21.9. What is the ratio of the Cost (current US$) of CO2 damage in Denmark to that in Germany?
Ensure brevity in your answer.  0.06. What is the ratio of the Cost (current US$) of Minerals in Denmark to that in Germany?
Provide a short and direct response. 6.79. What is the ratio of the Cost (current US$) in Energy in Denmark to that in Germany?
Your response must be concise. 0.16. What is the ratio of the Cost (current US$) in Forest in Denmark to that in Germany?
Offer a very short reply. 1.08. What is the ratio of the Cost (current US$) in CO2 damage in Denmark to that in Grenada?
Your answer should be compact. 448.91. What is the ratio of the Cost (current US$) in Minerals in Denmark to that in Grenada?
Your response must be concise. 7. What is the ratio of the Cost (current US$) of Energy in Denmark to that in Grenada?
Your answer should be compact. 6.51. What is the ratio of the Cost (current US$) in Forest in Denmark to that in Grenada?
Keep it short and to the point. 1094.43. What is the ratio of the Cost (current US$) of CO2 damage in Denmark to that in Guinea?
Keep it short and to the point. 50.56. What is the ratio of the Cost (current US$) in Minerals in Denmark to that in Guinea?
Provide a succinct answer. 0.66. What is the ratio of the Cost (current US$) of Energy in Denmark to that in Guinea?
Your response must be concise. 12.49. What is the ratio of the Cost (current US$) of Forest in Denmark to that in Guinea?
Provide a short and direct response. 58.91. What is the ratio of the Cost (current US$) in CO2 damage in Germany to that in Grenada?
Provide a short and direct response. 7371.03. What is the ratio of the Cost (current US$) of Minerals in Germany to that in Grenada?
Offer a very short reply. 1.03. What is the ratio of the Cost (current US$) in Energy in Germany to that in Grenada?
Keep it short and to the point. 41.8. What is the ratio of the Cost (current US$) in Forest in Germany to that in Grenada?
Your answer should be compact. 1011.47. What is the ratio of the Cost (current US$) of CO2 damage in Germany to that in Guinea?
Provide a short and direct response. 830.18. What is the ratio of the Cost (current US$) of Minerals in Germany to that in Guinea?
Provide a short and direct response. 0.1. What is the ratio of the Cost (current US$) of Energy in Germany to that in Guinea?
Offer a terse response. 80.17. What is the ratio of the Cost (current US$) in Forest in Germany to that in Guinea?
Your answer should be very brief. 54.44. What is the ratio of the Cost (current US$) in CO2 damage in Grenada to that in Guinea?
Your response must be concise. 0.11. What is the ratio of the Cost (current US$) in Minerals in Grenada to that in Guinea?
Ensure brevity in your answer.  0.09. What is the ratio of the Cost (current US$) of Energy in Grenada to that in Guinea?
Your response must be concise. 1.92. What is the ratio of the Cost (current US$) in Forest in Grenada to that in Guinea?
Make the answer very short. 0.05. What is the difference between the highest and the second highest Cost (current US$) of CO2 damage?
Your response must be concise. 4.48e+09. What is the difference between the highest and the second highest Cost (current US$) of Minerals?
Ensure brevity in your answer.  6.36e+07. What is the difference between the highest and the second highest Cost (current US$) of Energy?
Offer a terse response. 3.79e+08. What is the difference between the highest and the second highest Cost (current US$) in Forest?
Offer a terse response. 9.71e+07. What is the difference between the highest and the lowest Cost (current US$) of CO2 damage?
Your response must be concise. 4.77e+09. What is the difference between the highest and the lowest Cost (current US$) in Minerals?
Offer a terse response. 8.40e+07. What is the difference between the highest and the lowest Cost (current US$) in Energy?
Ensure brevity in your answer.  7.69e+08. What is the difference between the highest and the lowest Cost (current US$) in Forest?
Offer a very short reply. 1.28e+09. 